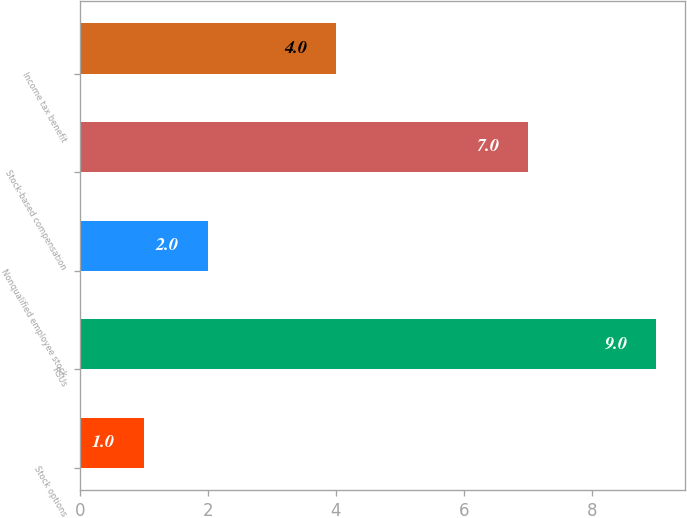Convert chart to OTSL. <chart><loc_0><loc_0><loc_500><loc_500><bar_chart><fcel>Stock options<fcel>RSUs<fcel>Nonqualified employee stock<fcel>Stock-based compensation<fcel>Income tax benefit<nl><fcel>1<fcel>9<fcel>2<fcel>7<fcel>4<nl></chart> 